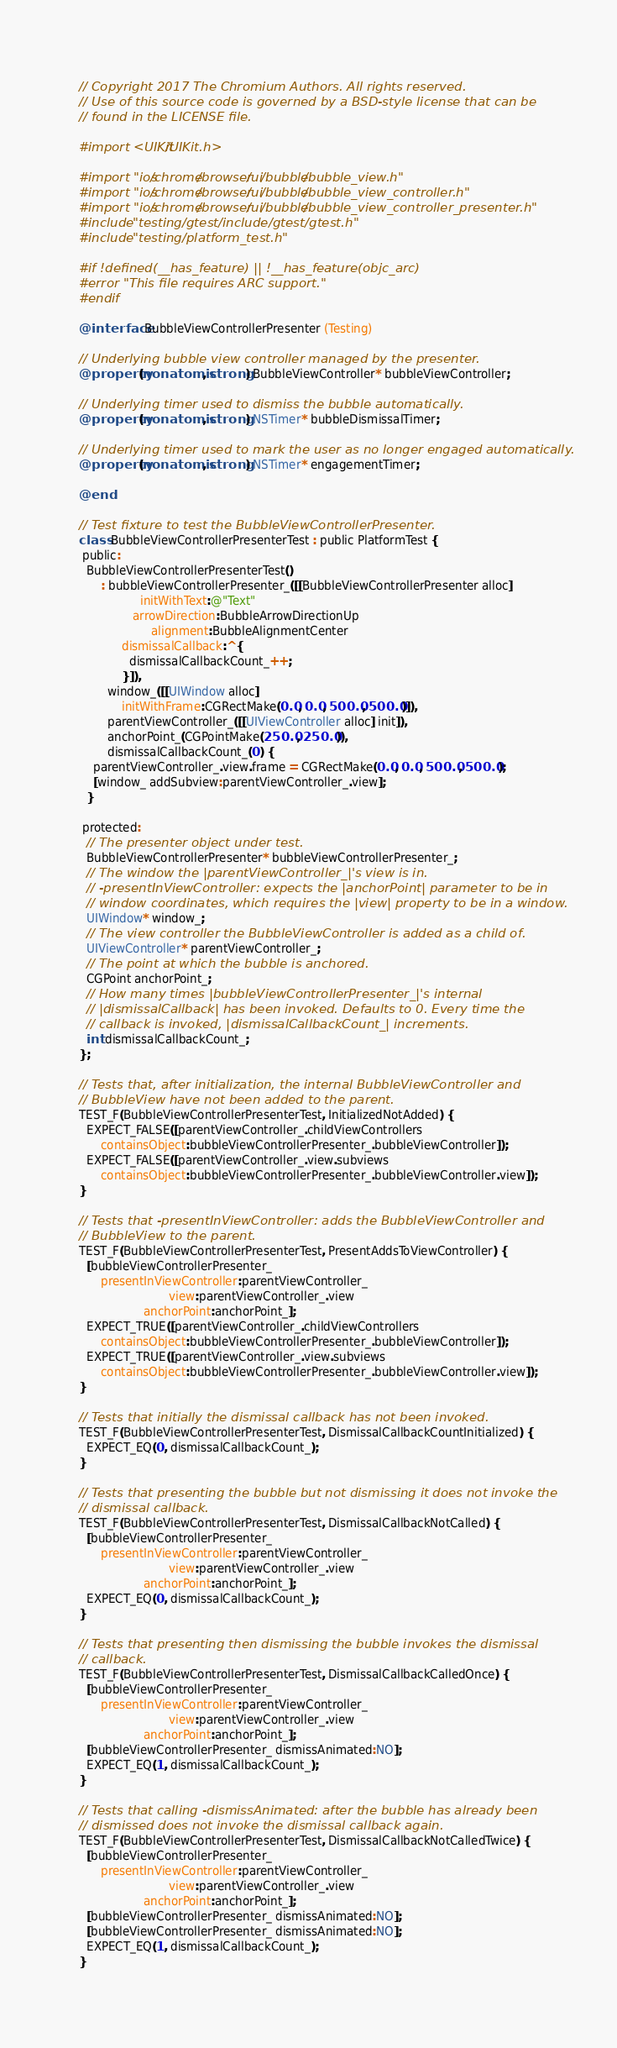Convert code to text. <code><loc_0><loc_0><loc_500><loc_500><_ObjectiveC_>// Copyright 2017 The Chromium Authors. All rights reserved.
// Use of this source code is governed by a BSD-style license that can be
// found in the LICENSE file.

#import <UIKit/UIKit.h>

#import "ios/chrome/browser/ui/bubble/bubble_view.h"
#import "ios/chrome/browser/ui/bubble/bubble_view_controller.h"
#import "ios/chrome/browser/ui/bubble/bubble_view_controller_presenter.h"
#include "testing/gtest/include/gtest/gtest.h"
#include "testing/platform_test.h"

#if !defined(__has_feature) || !__has_feature(objc_arc)
#error "This file requires ARC support."
#endif

@interface BubbleViewControllerPresenter (Testing)

// Underlying bubble view controller managed by the presenter.
@property(nonatomic, strong) BubbleViewController* bubbleViewController;

// Underlying timer used to dismiss the bubble automatically.
@property(nonatomic, strong) NSTimer* bubbleDismissalTimer;

// Underlying timer used to mark the user as no longer engaged automatically.
@property(nonatomic, strong) NSTimer* engagementTimer;

@end

// Test fixture to test the BubbleViewControllerPresenter.
class BubbleViewControllerPresenterTest : public PlatformTest {
 public:
  BubbleViewControllerPresenterTest()
      : bubbleViewControllerPresenter_([[BubbleViewControllerPresenter alloc]
                 initWithText:@"Text"
               arrowDirection:BubbleArrowDirectionUp
                    alignment:BubbleAlignmentCenter
            dismissalCallback:^{
              dismissalCallbackCount_++;
            }]),
        window_([[UIWindow alloc]
            initWithFrame:CGRectMake(0.0, 0.0, 500.0, 500.0)]),
        parentViewController_([[UIViewController alloc] init]),
        anchorPoint_(CGPointMake(250.0, 250.0)),
        dismissalCallbackCount_(0) {
    parentViewController_.view.frame = CGRectMake(0.0, 0.0, 500.0, 500.0);
    [window_ addSubview:parentViewController_.view];
  }

 protected:
  // The presenter object under test.
  BubbleViewControllerPresenter* bubbleViewControllerPresenter_;
  // The window the |parentViewController_|'s view is in.
  // -presentInViewController: expects the |anchorPoint| parameter to be in
  // window coordinates, which requires the |view| property to be in a window.
  UIWindow* window_;
  // The view controller the BubbleViewController is added as a child of.
  UIViewController* parentViewController_;
  // The point at which the bubble is anchored.
  CGPoint anchorPoint_;
  // How many times |bubbleViewControllerPresenter_|'s internal
  // |dismissalCallback| has been invoked. Defaults to 0. Every time the
  // callback is invoked, |dismissalCallbackCount_| increments.
  int dismissalCallbackCount_;
};

// Tests that, after initialization, the internal BubbleViewController and
// BubbleView have not been added to the parent.
TEST_F(BubbleViewControllerPresenterTest, InitializedNotAdded) {
  EXPECT_FALSE([parentViewController_.childViewControllers
      containsObject:bubbleViewControllerPresenter_.bubbleViewController]);
  EXPECT_FALSE([parentViewController_.view.subviews
      containsObject:bubbleViewControllerPresenter_.bubbleViewController.view]);
}

// Tests that -presentInViewController: adds the BubbleViewController and
// BubbleView to the parent.
TEST_F(BubbleViewControllerPresenterTest, PresentAddsToViewController) {
  [bubbleViewControllerPresenter_
      presentInViewController:parentViewController_
                         view:parentViewController_.view
                  anchorPoint:anchorPoint_];
  EXPECT_TRUE([parentViewController_.childViewControllers
      containsObject:bubbleViewControllerPresenter_.bubbleViewController]);
  EXPECT_TRUE([parentViewController_.view.subviews
      containsObject:bubbleViewControllerPresenter_.bubbleViewController.view]);
}

// Tests that initially the dismissal callback has not been invoked.
TEST_F(BubbleViewControllerPresenterTest, DismissalCallbackCountInitialized) {
  EXPECT_EQ(0, dismissalCallbackCount_);
}

// Tests that presenting the bubble but not dismissing it does not invoke the
// dismissal callback.
TEST_F(BubbleViewControllerPresenterTest, DismissalCallbackNotCalled) {
  [bubbleViewControllerPresenter_
      presentInViewController:parentViewController_
                         view:parentViewController_.view
                  anchorPoint:anchorPoint_];
  EXPECT_EQ(0, dismissalCallbackCount_);
}

// Tests that presenting then dismissing the bubble invokes the dismissal
// callback.
TEST_F(BubbleViewControllerPresenterTest, DismissalCallbackCalledOnce) {
  [bubbleViewControllerPresenter_
      presentInViewController:parentViewController_
                         view:parentViewController_.view
                  anchorPoint:anchorPoint_];
  [bubbleViewControllerPresenter_ dismissAnimated:NO];
  EXPECT_EQ(1, dismissalCallbackCount_);
}

// Tests that calling -dismissAnimated: after the bubble has already been
// dismissed does not invoke the dismissal callback again.
TEST_F(BubbleViewControllerPresenterTest, DismissalCallbackNotCalledTwice) {
  [bubbleViewControllerPresenter_
      presentInViewController:parentViewController_
                         view:parentViewController_.view
                  anchorPoint:anchorPoint_];
  [bubbleViewControllerPresenter_ dismissAnimated:NO];
  [bubbleViewControllerPresenter_ dismissAnimated:NO];
  EXPECT_EQ(1, dismissalCallbackCount_);
}
</code> 